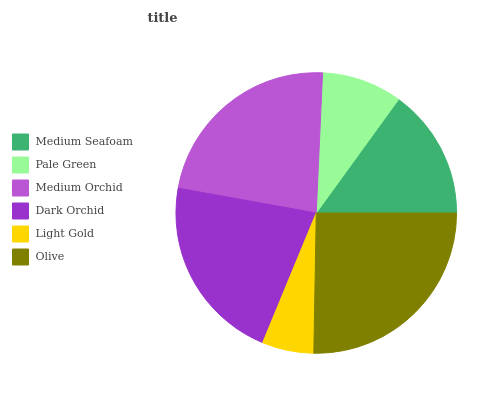Is Light Gold the minimum?
Answer yes or no. Yes. Is Olive the maximum?
Answer yes or no. Yes. Is Pale Green the minimum?
Answer yes or no. No. Is Pale Green the maximum?
Answer yes or no. No. Is Medium Seafoam greater than Pale Green?
Answer yes or no. Yes. Is Pale Green less than Medium Seafoam?
Answer yes or no. Yes. Is Pale Green greater than Medium Seafoam?
Answer yes or no. No. Is Medium Seafoam less than Pale Green?
Answer yes or no. No. Is Dark Orchid the high median?
Answer yes or no. Yes. Is Medium Seafoam the low median?
Answer yes or no. Yes. Is Light Gold the high median?
Answer yes or no. No. Is Medium Orchid the low median?
Answer yes or no. No. 